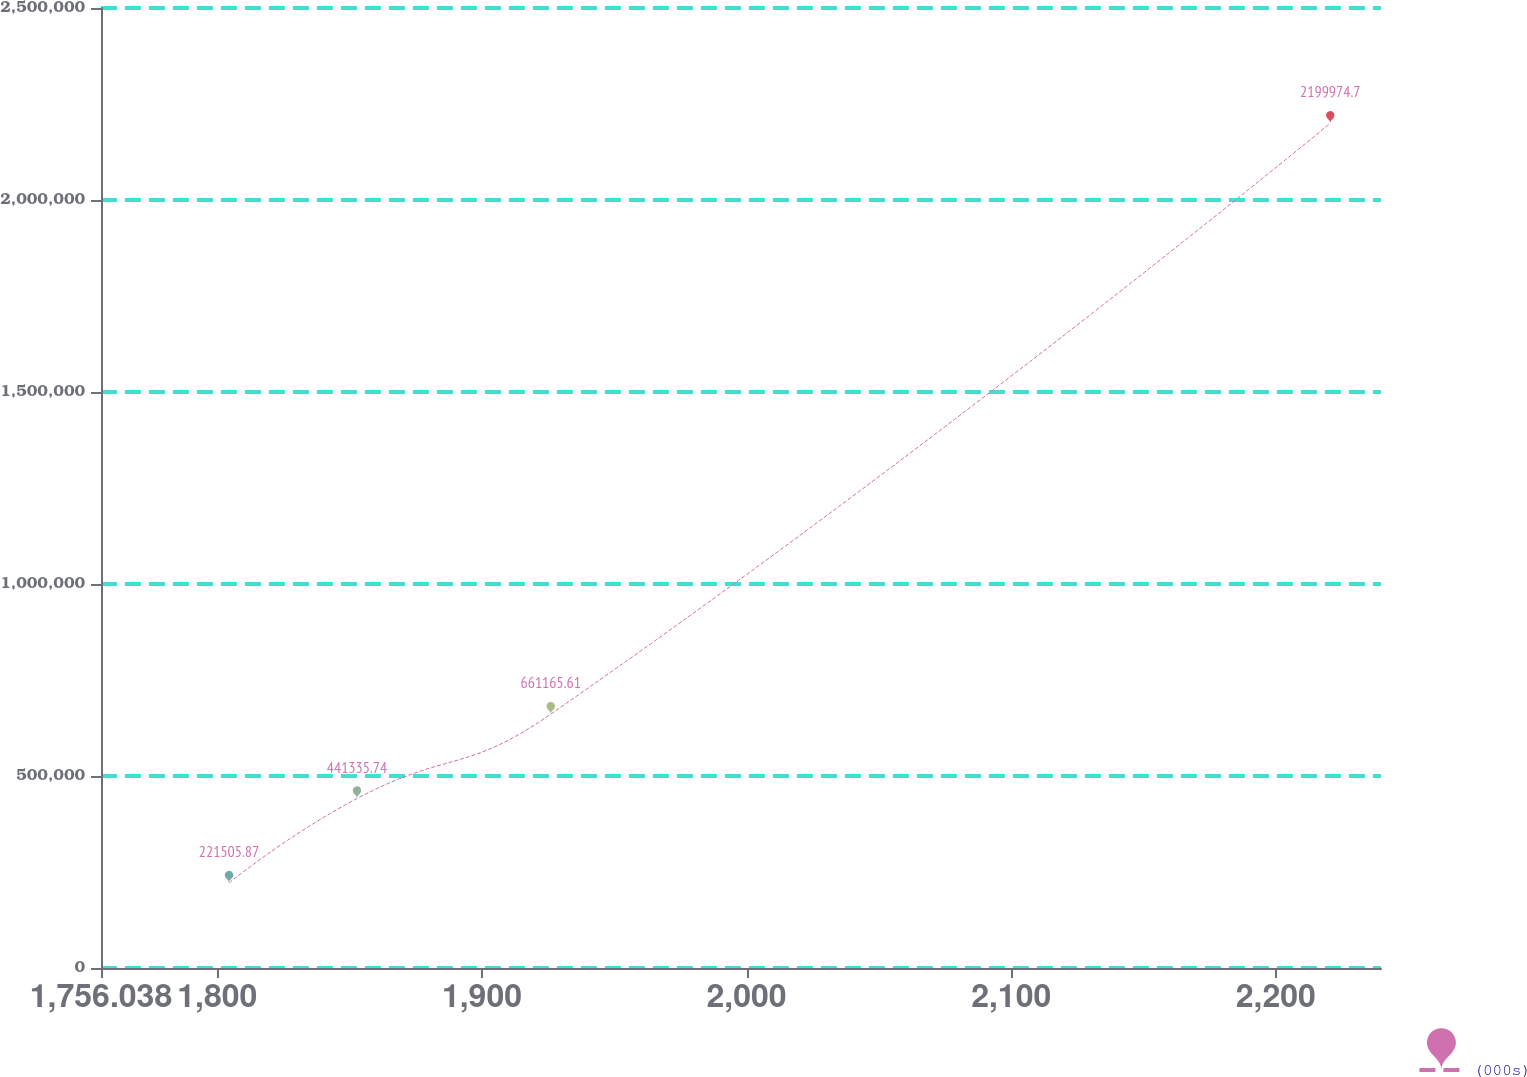Convert chart. <chart><loc_0><loc_0><loc_500><loc_500><line_chart><ecel><fcel>(000s)<nl><fcel>1804.41<fcel>221506<nl><fcel>1852.78<fcel>441336<nl><fcel>1926<fcel>661166<nl><fcel>2220.59<fcel>2.19997e+06<nl><fcel>2288.13<fcel>1676<nl></chart> 